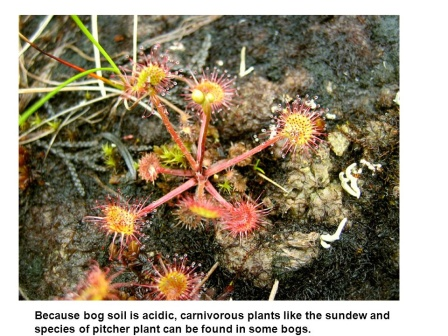How do the sticky droplets on the sundews' leaves work? The sticky droplets on the sundews' leaves are actually a form of glandular secretion. These droplets are highly attractive to insects, drawing them in with the promise of nectar. However, when an insect lands on the droplet-covered leaf, it becomes trapped in the sticky substance. The leaf then slowly curls around the insect, secreting digestive enzymes to break it down into nutrients that the plant can absorb. Do pitcher plants have any specific adaptations for trapping insects? Yes, pitcher plants have several fascinating adaptations. Their tube-like leaves form a deep cavity filled with digestive fluid. The rim of the pitcher is often slippery and lined with nectar to lure insects. Once an insect slips and falls into the cavity, it finds it nearly impossible to escape due to the downward-facing hairs inside the pitcher. These hairs prevent the insect from climbing out, and it eventually drowns in the digestive fluid, where it's broken down into nutrients for the plant. 